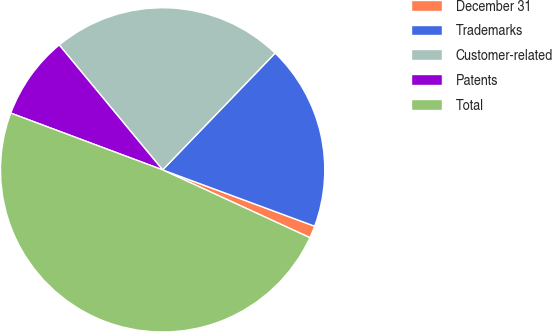Convert chart. <chart><loc_0><loc_0><loc_500><loc_500><pie_chart><fcel>December 31<fcel>Trademarks<fcel>Customer-related<fcel>Patents<fcel>Total<nl><fcel>1.22%<fcel>18.44%<fcel>23.21%<fcel>8.3%<fcel>48.83%<nl></chart> 